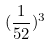Convert formula to latex. <formula><loc_0><loc_0><loc_500><loc_500>( \frac { 1 } { 5 2 } ) ^ { 3 }</formula> 